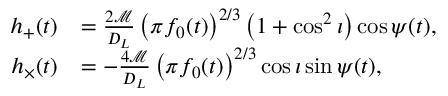Convert formula to latex. <formula><loc_0><loc_0><loc_500><loc_500>\begin{array} { r l } { h _ { + } ( t ) } & { = \frac { 2 \mathcal { M } } { D _ { L } } \left ( \pi f _ { 0 } ( t ) \right ) ^ { 2 / 3 } \left ( 1 + \cos ^ { 2 } \iota \right ) \cos { \psi ( t ) } , } \\ { h _ { \times } ( t ) } & { = - \frac { 4 \mathcal { M } } { D _ { L } } \left ( \pi f _ { 0 } ( t ) \right ) ^ { 2 / 3 } \cos { \iota } \sin { \psi ( t ) } , } \end{array}</formula> 